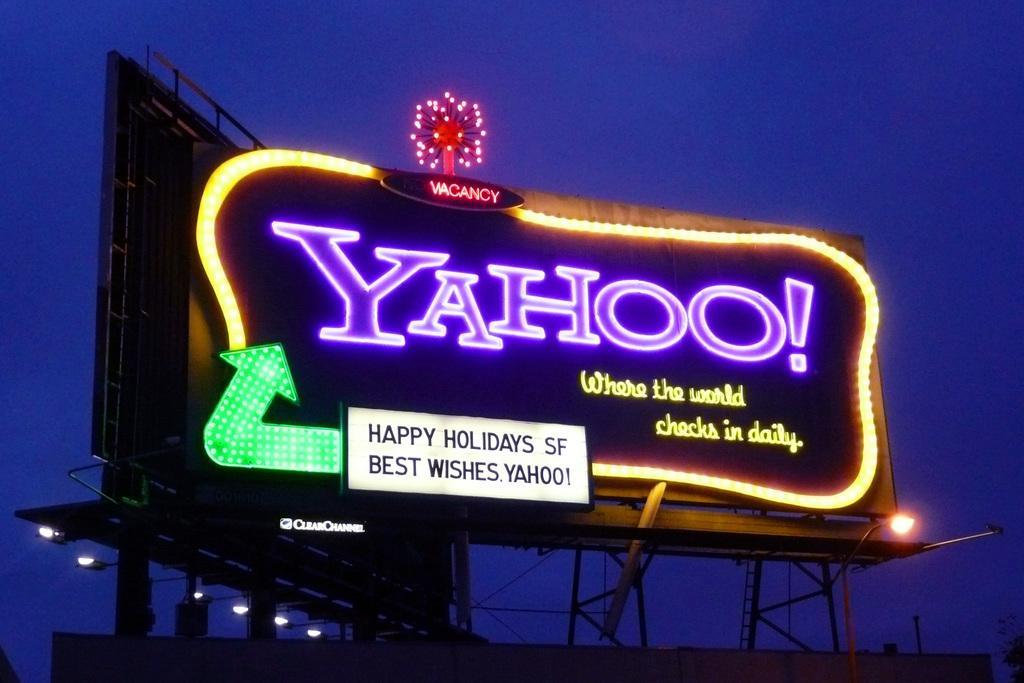Please provide a concise description of this image. In this image there are two advertising boards as we can see in the middle of this image. There is some text written on the board as we can see in the middle of this image. There are some lights arranged to the border of this board. There are some lights in the bottom of this image as well. There is a sky in the background. 